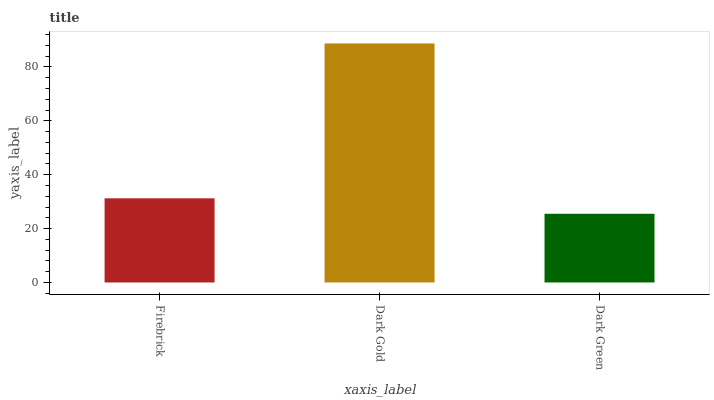Is Dark Green the minimum?
Answer yes or no. Yes. Is Dark Gold the maximum?
Answer yes or no. Yes. Is Dark Gold the minimum?
Answer yes or no. No. Is Dark Green the maximum?
Answer yes or no. No. Is Dark Gold greater than Dark Green?
Answer yes or no. Yes. Is Dark Green less than Dark Gold?
Answer yes or no. Yes. Is Dark Green greater than Dark Gold?
Answer yes or no. No. Is Dark Gold less than Dark Green?
Answer yes or no. No. Is Firebrick the high median?
Answer yes or no. Yes. Is Firebrick the low median?
Answer yes or no. Yes. Is Dark Green the high median?
Answer yes or no. No. Is Dark Gold the low median?
Answer yes or no. No. 